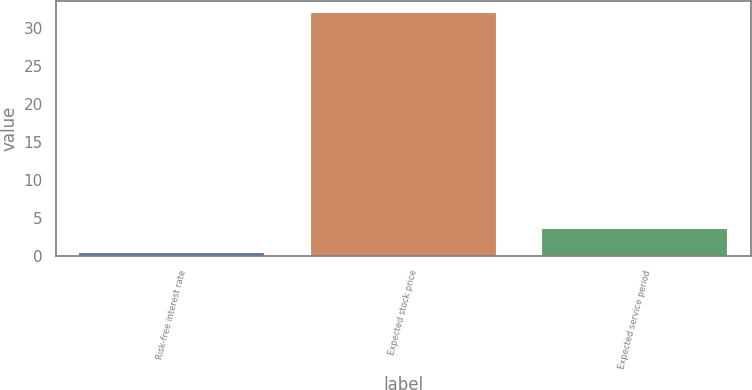Convert chart. <chart><loc_0><loc_0><loc_500><loc_500><bar_chart><fcel>Risk-free interest rate<fcel>Expected stock price<fcel>Expected service period<nl><fcel>0.4<fcel>31.9<fcel>3.55<nl></chart> 